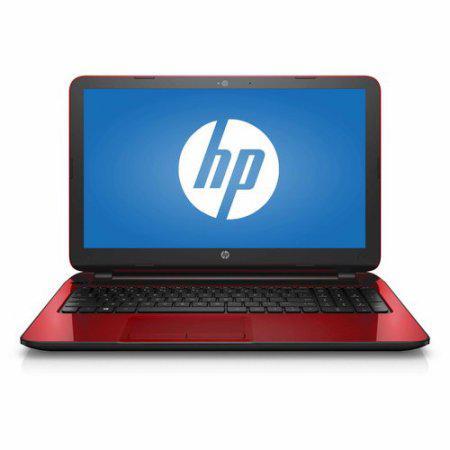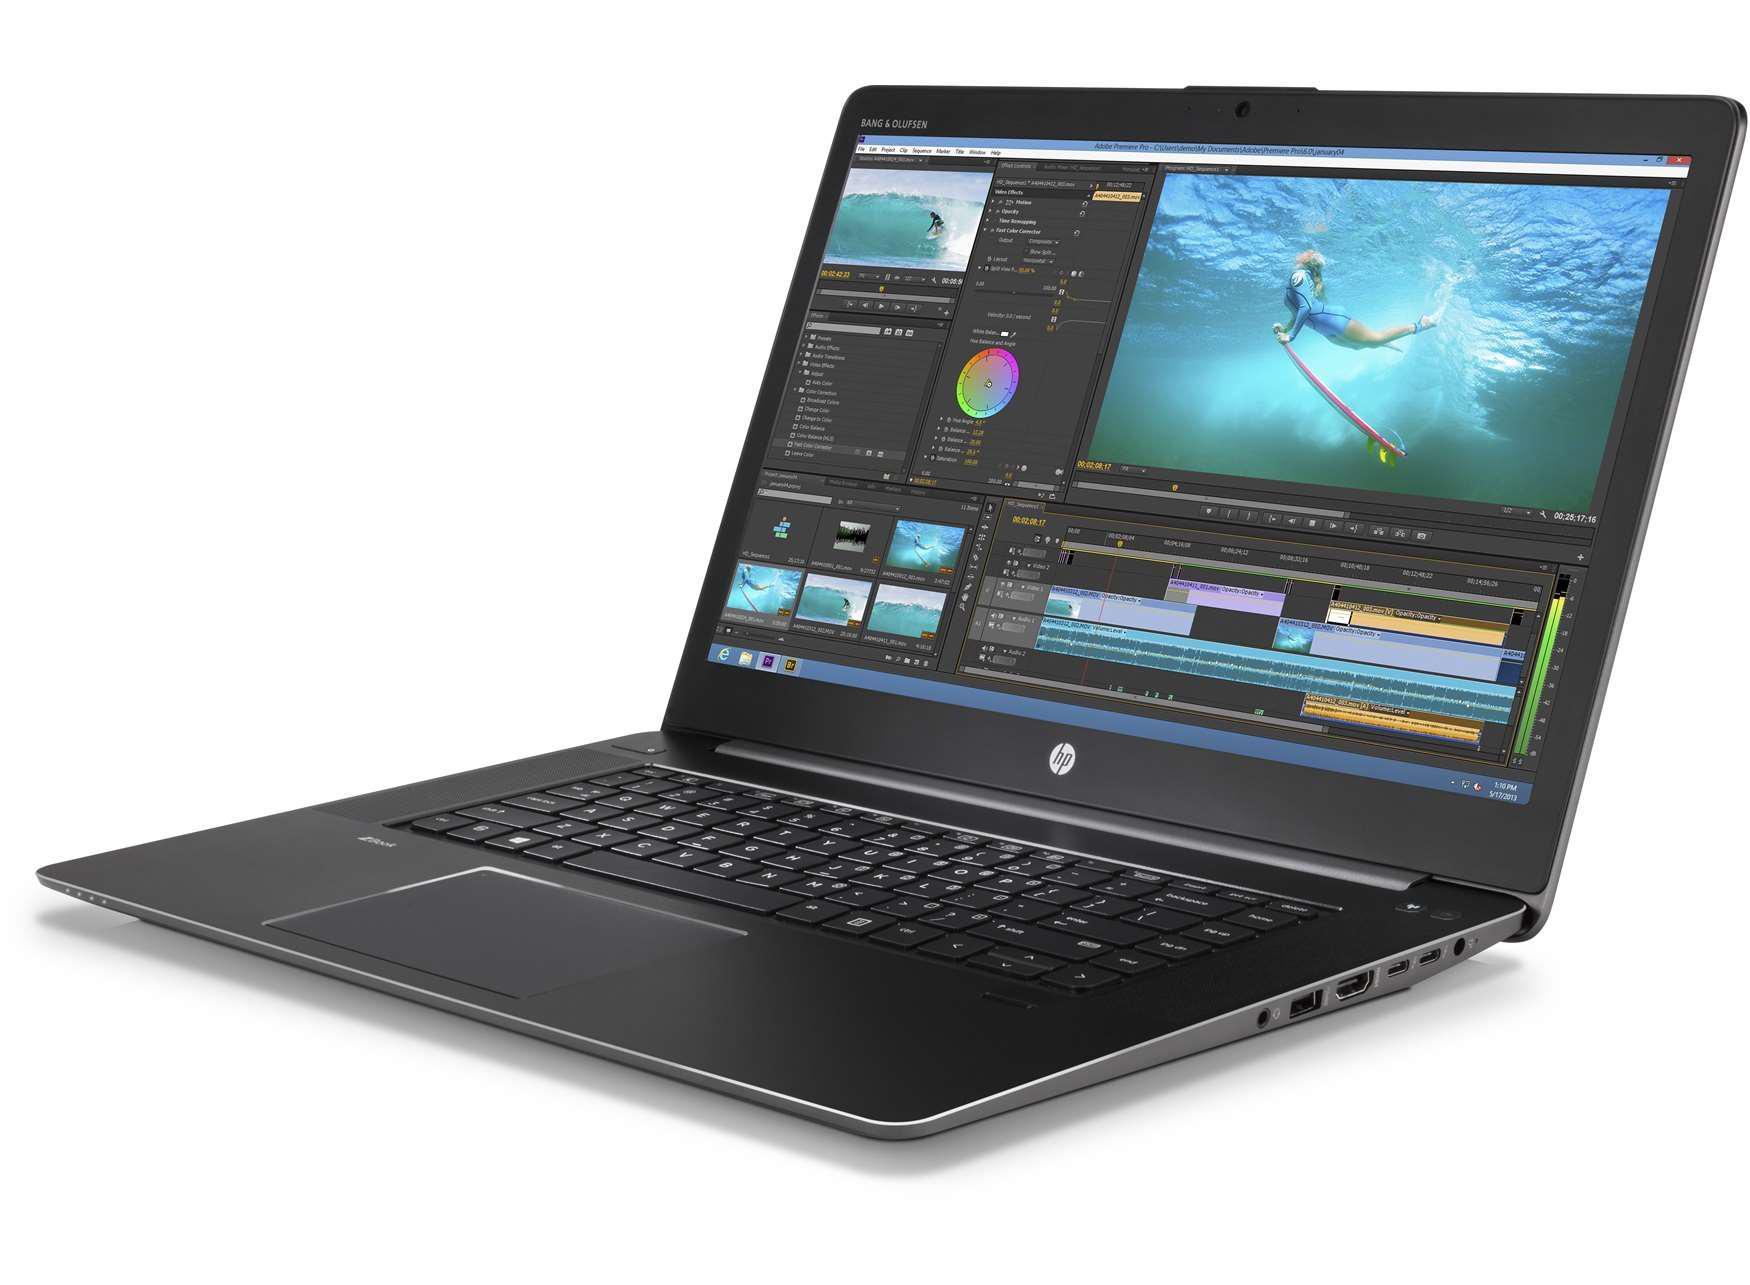The first image is the image on the left, the second image is the image on the right. Analyze the images presented: Is the assertion "The laptop in the image on the left is facing forward." valid? Answer yes or no. Yes. 